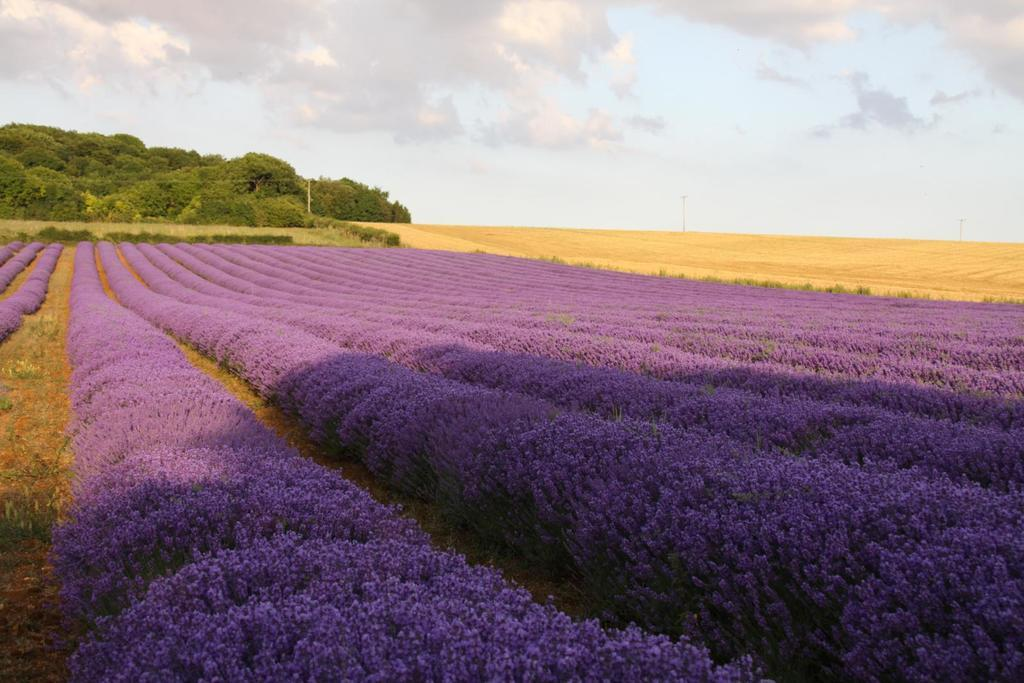What is the main subject of the image? The main subject of the image is a flowers field. Where are the trees located in the image? The trees are at the top side of the image. Can you describe the landscape in the image? The landscape consists of a flowers field and trees. What type of game is being played in the flowers field? There is no game being played in the flowers field; the image only shows the flowers field and trees. 